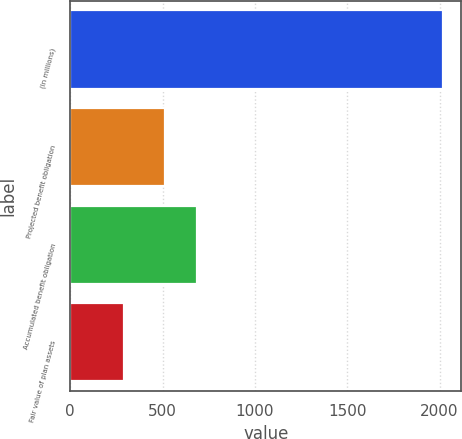Convert chart. <chart><loc_0><loc_0><loc_500><loc_500><bar_chart><fcel>(In millions)<fcel>Projected benefit obligation<fcel>Accumulated benefit obligation<fcel>Fair value of plan assets<nl><fcel>2017<fcel>513<fcel>685.4<fcel>293<nl></chart> 